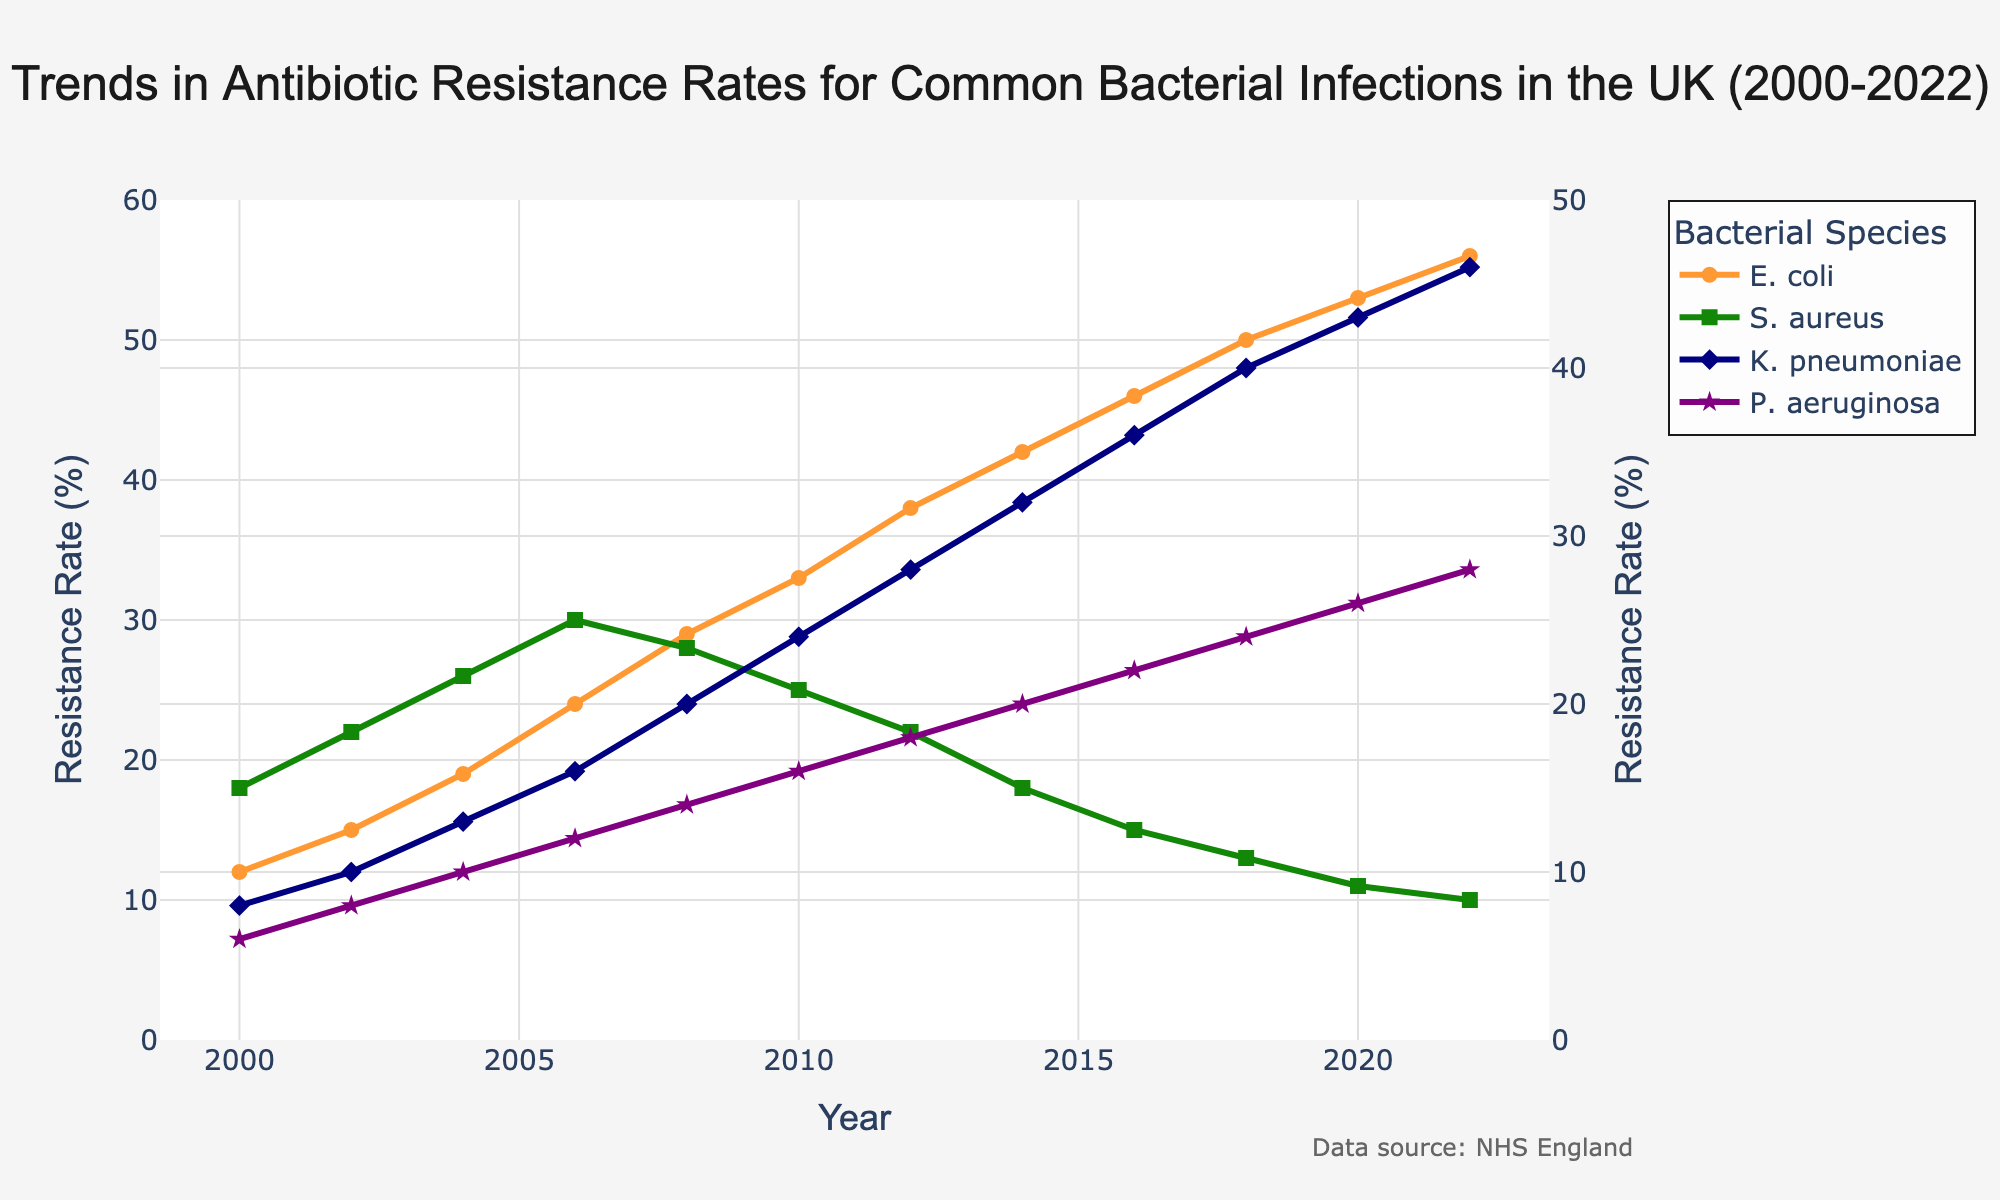What is the trend in antibiotic resistance rates for E. coli over the period 2000 to 2022? Observing the line for E. coli, it starts at 12% in 2000 and increases gradually each year, reaching 56% in 2022. This indicates a continuous upward trend.
Answer: Continuous upward trend Which bacterial infection exhibits the highest resistance rate in 2022? By comparing the terminal points (year 2022) of all lines, E. coli has a resistance rate of 56%, which is higher than the other bacterial infections.
Answer: E. coli How does the resistance rate of S. aureus in 2020 compare to its rate in 2008? Checking the points for S. aureus in 2008 and 2020, the resistance rate drops from 28% in 2008 to 11% in 2020.
Answer: Decreased What is the average resistance rate of K. pneumoniae from 2000 to 2022? Summing the resistance rates for K. pneumoniae from each year (8+10+13+16+20+24+28+32+36+40+43+46 = 316), then dividing by 12 (the number of years), gives an average of 316/12.
Answer: 26.33% Which bacterial infection has the lowest resistance rate in the year 2012? Observing the resistance rates in 2012, S. aureus has a resistance rate of 22%, which is the lowest among all listed infections.
Answer: S. aureus By how much did the resistance rate of P. aeruginosa increase from 2000 to 2022? Subtracting the resistance rate of P. aeruginosa in 2000 (6%) from the rate in 2022 (28%) gives the increase: 28% - 6%.
Answer: 22% Between 2008 and 2012, which bacterial infection showed the most significant decrease in resistance rate? Comparing the changes between 2008 and 2012, S. aureus decreased from 28% to 22%, which is a 6% decrease, the most significant change among the infections.
Answer: S. aureus What is the difference between the resistance rates of K. pneumoniae and P. aeruginosa in 2018? Subtracting the resistance rate of P. aeruginosa in 2018 (24%) from K. pneumoniae's rate in the same year (40%) gives 40% - 24%.
Answer: 16% Which bacterial infection reached a resistance rate of more than 50% first, and in which year? Observing the trends, E. coli surpassed 50% in 2018, whereas other infections have not reached this threshold.
Answer: E. coli in 2018 